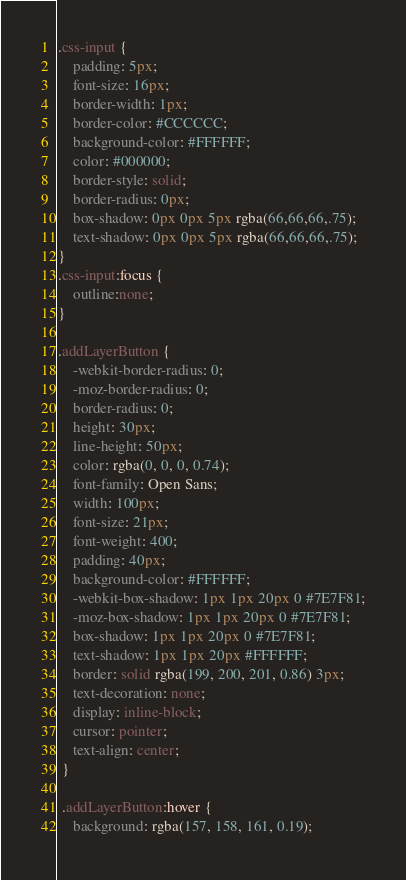Convert code to text. <code><loc_0><loc_0><loc_500><loc_500><_CSS_>.css-input {
    padding: 5px;
    font-size: 16px;
    border-width: 1px;
    border-color: #CCCCCC;
    background-color: #FFFFFF;
    color: #000000;
    border-style: solid;
    border-radius: 0px;
    box-shadow: 0px 0px 5px rgba(66,66,66,.75);
    text-shadow: 0px 0px 5px rgba(66,66,66,.75);
}
.css-input:focus {
    outline:none;
}

.addLayerButton {
    -webkit-border-radius: 0;
    -moz-border-radius: 0;
    border-radius: 0;
    height: 30px;
    line-height: 50px;
    color: rgba(0, 0, 0, 0.74);
    font-family: Open Sans;
    width: 100px;
    font-size: 21px;
    font-weight: 400;
    padding: 40px;
    background-color: #FFFFFF;
    -webkit-box-shadow: 1px 1px 20px 0 #7E7F81;
    -moz-box-shadow: 1px 1px 20px 0 #7E7F81;
    box-shadow: 1px 1px 20px 0 #7E7F81;
    text-shadow: 1px 1px 20px #FFFFFF;
    border: solid rgba(199, 200, 201, 0.86) 3px;
    text-decoration: none;
    display: inline-block;
    cursor: pointer;
    text-align: center;
 }
 
 .addLayerButton:hover {
    background: rgba(157, 158, 161, 0.19);</code> 